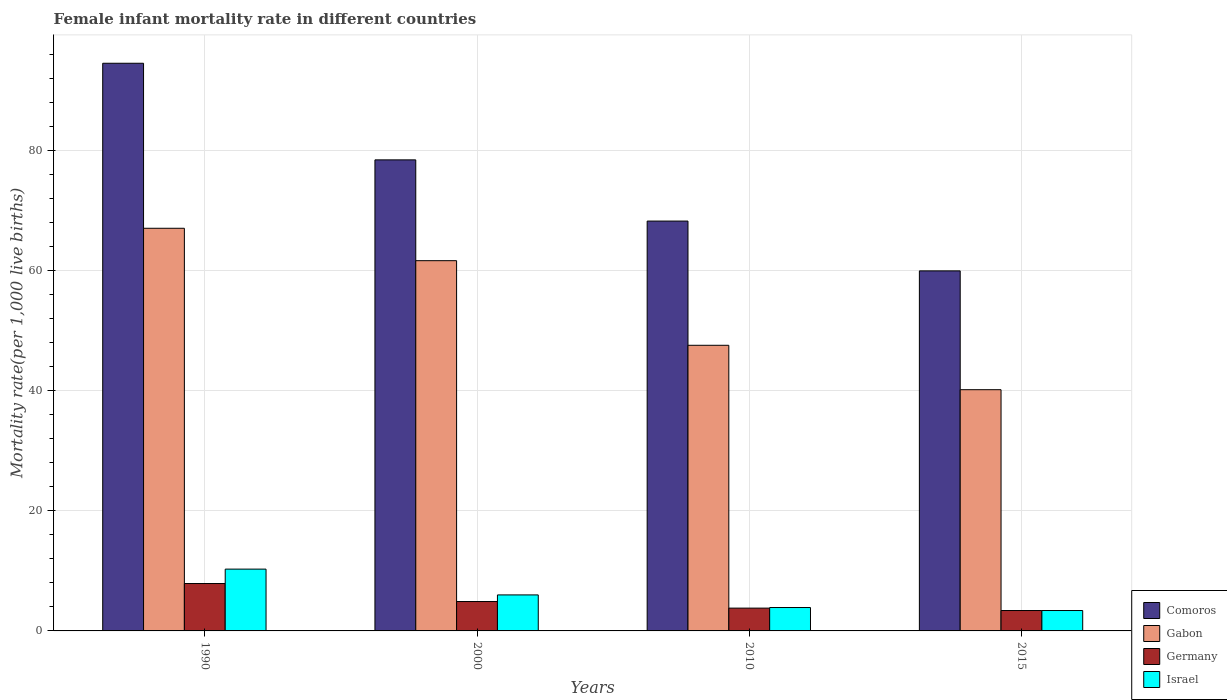Are the number of bars per tick equal to the number of legend labels?
Your answer should be compact. Yes. What is the label of the 3rd group of bars from the left?
Offer a very short reply. 2010. What is the female infant mortality rate in Germany in 2010?
Provide a short and direct response. 3.8. Across all years, what is the maximum female infant mortality rate in Gabon?
Make the answer very short. 67.1. Across all years, what is the minimum female infant mortality rate in Comoros?
Your answer should be compact. 60. In which year was the female infant mortality rate in Comoros minimum?
Your response must be concise. 2015. What is the total female infant mortality rate in Comoros in the graph?
Offer a very short reply. 301.4. What is the difference between the female infant mortality rate in Gabon in 1990 and that in 2000?
Make the answer very short. 5.4. What is the difference between the female infant mortality rate in Comoros in 2000 and the female infant mortality rate in Gabon in 2015?
Keep it short and to the point. 38.3. What is the average female infant mortality rate in Israel per year?
Ensure brevity in your answer.  5.9. In the year 2010, what is the difference between the female infant mortality rate in Comoros and female infant mortality rate in Gabon?
Your answer should be very brief. 20.7. What is the ratio of the female infant mortality rate in Comoros in 2000 to that in 2015?
Offer a very short reply. 1.31. Is the female infant mortality rate in Israel in 2000 less than that in 2010?
Keep it short and to the point. No. What is the difference between the highest and the second highest female infant mortality rate in Comoros?
Keep it short and to the point. 16.1. What does the 1st bar from the left in 1990 represents?
Offer a very short reply. Comoros. What does the 4th bar from the right in 2000 represents?
Your answer should be compact. Comoros. Is it the case that in every year, the sum of the female infant mortality rate in Comoros and female infant mortality rate in Gabon is greater than the female infant mortality rate in Israel?
Offer a terse response. Yes. How many bars are there?
Your response must be concise. 16. How many years are there in the graph?
Keep it short and to the point. 4. What is the difference between two consecutive major ticks on the Y-axis?
Your answer should be compact. 20. Does the graph contain grids?
Provide a succinct answer. Yes. Where does the legend appear in the graph?
Your answer should be compact. Bottom right. What is the title of the graph?
Provide a succinct answer. Female infant mortality rate in different countries. What is the label or title of the X-axis?
Offer a terse response. Years. What is the label or title of the Y-axis?
Offer a very short reply. Mortality rate(per 1,0 live births). What is the Mortality rate(per 1,000 live births) of Comoros in 1990?
Your response must be concise. 94.6. What is the Mortality rate(per 1,000 live births) of Gabon in 1990?
Your answer should be compact. 67.1. What is the Mortality rate(per 1,000 live births) of Germany in 1990?
Give a very brief answer. 7.9. What is the Mortality rate(per 1,000 live births) in Israel in 1990?
Make the answer very short. 10.3. What is the Mortality rate(per 1,000 live births) of Comoros in 2000?
Offer a terse response. 78.5. What is the Mortality rate(per 1,000 live births) in Gabon in 2000?
Keep it short and to the point. 61.7. What is the Mortality rate(per 1,000 live births) of Germany in 2000?
Keep it short and to the point. 4.9. What is the Mortality rate(per 1,000 live births) of Comoros in 2010?
Keep it short and to the point. 68.3. What is the Mortality rate(per 1,000 live births) of Gabon in 2010?
Your answer should be compact. 47.6. What is the Mortality rate(per 1,000 live births) of Gabon in 2015?
Your answer should be very brief. 40.2. What is the Mortality rate(per 1,000 live births) of Germany in 2015?
Provide a succinct answer. 3.4. Across all years, what is the maximum Mortality rate(per 1,000 live births) of Comoros?
Provide a succinct answer. 94.6. Across all years, what is the maximum Mortality rate(per 1,000 live births) of Gabon?
Provide a succinct answer. 67.1. Across all years, what is the maximum Mortality rate(per 1,000 live births) of Israel?
Provide a succinct answer. 10.3. Across all years, what is the minimum Mortality rate(per 1,000 live births) of Comoros?
Offer a terse response. 60. Across all years, what is the minimum Mortality rate(per 1,000 live births) of Gabon?
Keep it short and to the point. 40.2. Across all years, what is the minimum Mortality rate(per 1,000 live births) in Israel?
Provide a short and direct response. 3.4. What is the total Mortality rate(per 1,000 live births) of Comoros in the graph?
Your answer should be compact. 301.4. What is the total Mortality rate(per 1,000 live births) in Gabon in the graph?
Offer a terse response. 216.6. What is the total Mortality rate(per 1,000 live births) of Germany in the graph?
Offer a terse response. 20. What is the total Mortality rate(per 1,000 live births) of Israel in the graph?
Offer a very short reply. 23.6. What is the difference between the Mortality rate(per 1,000 live births) in Germany in 1990 and that in 2000?
Keep it short and to the point. 3. What is the difference between the Mortality rate(per 1,000 live births) of Israel in 1990 and that in 2000?
Provide a succinct answer. 4.3. What is the difference between the Mortality rate(per 1,000 live births) of Comoros in 1990 and that in 2010?
Give a very brief answer. 26.3. What is the difference between the Mortality rate(per 1,000 live births) of Gabon in 1990 and that in 2010?
Ensure brevity in your answer.  19.5. What is the difference between the Mortality rate(per 1,000 live births) of Germany in 1990 and that in 2010?
Ensure brevity in your answer.  4.1. What is the difference between the Mortality rate(per 1,000 live births) of Israel in 1990 and that in 2010?
Offer a terse response. 6.4. What is the difference between the Mortality rate(per 1,000 live births) of Comoros in 1990 and that in 2015?
Give a very brief answer. 34.6. What is the difference between the Mortality rate(per 1,000 live births) of Gabon in 1990 and that in 2015?
Ensure brevity in your answer.  26.9. What is the difference between the Mortality rate(per 1,000 live births) in Germany in 2000 and that in 2010?
Offer a terse response. 1.1. What is the difference between the Mortality rate(per 1,000 live births) in Israel in 2000 and that in 2010?
Your answer should be very brief. 2.1. What is the difference between the Mortality rate(per 1,000 live births) in Gabon in 2000 and that in 2015?
Offer a terse response. 21.5. What is the difference between the Mortality rate(per 1,000 live births) in Israel in 2000 and that in 2015?
Offer a very short reply. 2.6. What is the difference between the Mortality rate(per 1,000 live births) in Gabon in 2010 and that in 2015?
Give a very brief answer. 7.4. What is the difference between the Mortality rate(per 1,000 live births) in Israel in 2010 and that in 2015?
Make the answer very short. 0.5. What is the difference between the Mortality rate(per 1,000 live births) of Comoros in 1990 and the Mortality rate(per 1,000 live births) of Gabon in 2000?
Give a very brief answer. 32.9. What is the difference between the Mortality rate(per 1,000 live births) in Comoros in 1990 and the Mortality rate(per 1,000 live births) in Germany in 2000?
Provide a succinct answer. 89.7. What is the difference between the Mortality rate(per 1,000 live births) in Comoros in 1990 and the Mortality rate(per 1,000 live births) in Israel in 2000?
Keep it short and to the point. 88.6. What is the difference between the Mortality rate(per 1,000 live births) of Gabon in 1990 and the Mortality rate(per 1,000 live births) of Germany in 2000?
Provide a short and direct response. 62.2. What is the difference between the Mortality rate(per 1,000 live births) in Gabon in 1990 and the Mortality rate(per 1,000 live births) in Israel in 2000?
Provide a succinct answer. 61.1. What is the difference between the Mortality rate(per 1,000 live births) of Germany in 1990 and the Mortality rate(per 1,000 live births) of Israel in 2000?
Your response must be concise. 1.9. What is the difference between the Mortality rate(per 1,000 live births) of Comoros in 1990 and the Mortality rate(per 1,000 live births) of Gabon in 2010?
Your answer should be compact. 47. What is the difference between the Mortality rate(per 1,000 live births) of Comoros in 1990 and the Mortality rate(per 1,000 live births) of Germany in 2010?
Offer a terse response. 90.8. What is the difference between the Mortality rate(per 1,000 live births) in Comoros in 1990 and the Mortality rate(per 1,000 live births) in Israel in 2010?
Your answer should be compact. 90.7. What is the difference between the Mortality rate(per 1,000 live births) in Gabon in 1990 and the Mortality rate(per 1,000 live births) in Germany in 2010?
Make the answer very short. 63.3. What is the difference between the Mortality rate(per 1,000 live births) of Gabon in 1990 and the Mortality rate(per 1,000 live births) of Israel in 2010?
Offer a very short reply. 63.2. What is the difference between the Mortality rate(per 1,000 live births) of Germany in 1990 and the Mortality rate(per 1,000 live births) of Israel in 2010?
Provide a short and direct response. 4. What is the difference between the Mortality rate(per 1,000 live births) in Comoros in 1990 and the Mortality rate(per 1,000 live births) in Gabon in 2015?
Make the answer very short. 54.4. What is the difference between the Mortality rate(per 1,000 live births) of Comoros in 1990 and the Mortality rate(per 1,000 live births) of Germany in 2015?
Make the answer very short. 91.2. What is the difference between the Mortality rate(per 1,000 live births) in Comoros in 1990 and the Mortality rate(per 1,000 live births) in Israel in 2015?
Keep it short and to the point. 91.2. What is the difference between the Mortality rate(per 1,000 live births) of Gabon in 1990 and the Mortality rate(per 1,000 live births) of Germany in 2015?
Provide a succinct answer. 63.7. What is the difference between the Mortality rate(per 1,000 live births) of Gabon in 1990 and the Mortality rate(per 1,000 live births) of Israel in 2015?
Give a very brief answer. 63.7. What is the difference between the Mortality rate(per 1,000 live births) of Germany in 1990 and the Mortality rate(per 1,000 live births) of Israel in 2015?
Keep it short and to the point. 4.5. What is the difference between the Mortality rate(per 1,000 live births) in Comoros in 2000 and the Mortality rate(per 1,000 live births) in Gabon in 2010?
Make the answer very short. 30.9. What is the difference between the Mortality rate(per 1,000 live births) of Comoros in 2000 and the Mortality rate(per 1,000 live births) of Germany in 2010?
Make the answer very short. 74.7. What is the difference between the Mortality rate(per 1,000 live births) in Comoros in 2000 and the Mortality rate(per 1,000 live births) in Israel in 2010?
Give a very brief answer. 74.6. What is the difference between the Mortality rate(per 1,000 live births) of Gabon in 2000 and the Mortality rate(per 1,000 live births) of Germany in 2010?
Offer a very short reply. 57.9. What is the difference between the Mortality rate(per 1,000 live births) in Gabon in 2000 and the Mortality rate(per 1,000 live births) in Israel in 2010?
Your answer should be compact. 57.8. What is the difference between the Mortality rate(per 1,000 live births) in Comoros in 2000 and the Mortality rate(per 1,000 live births) in Gabon in 2015?
Offer a terse response. 38.3. What is the difference between the Mortality rate(per 1,000 live births) in Comoros in 2000 and the Mortality rate(per 1,000 live births) in Germany in 2015?
Give a very brief answer. 75.1. What is the difference between the Mortality rate(per 1,000 live births) in Comoros in 2000 and the Mortality rate(per 1,000 live births) in Israel in 2015?
Offer a very short reply. 75.1. What is the difference between the Mortality rate(per 1,000 live births) in Gabon in 2000 and the Mortality rate(per 1,000 live births) in Germany in 2015?
Provide a short and direct response. 58.3. What is the difference between the Mortality rate(per 1,000 live births) of Gabon in 2000 and the Mortality rate(per 1,000 live births) of Israel in 2015?
Your response must be concise. 58.3. What is the difference between the Mortality rate(per 1,000 live births) in Comoros in 2010 and the Mortality rate(per 1,000 live births) in Gabon in 2015?
Provide a succinct answer. 28.1. What is the difference between the Mortality rate(per 1,000 live births) in Comoros in 2010 and the Mortality rate(per 1,000 live births) in Germany in 2015?
Keep it short and to the point. 64.9. What is the difference between the Mortality rate(per 1,000 live births) of Comoros in 2010 and the Mortality rate(per 1,000 live births) of Israel in 2015?
Your answer should be very brief. 64.9. What is the difference between the Mortality rate(per 1,000 live births) in Gabon in 2010 and the Mortality rate(per 1,000 live births) in Germany in 2015?
Your answer should be very brief. 44.2. What is the difference between the Mortality rate(per 1,000 live births) of Gabon in 2010 and the Mortality rate(per 1,000 live births) of Israel in 2015?
Provide a succinct answer. 44.2. What is the difference between the Mortality rate(per 1,000 live births) in Germany in 2010 and the Mortality rate(per 1,000 live births) in Israel in 2015?
Give a very brief answer. 0.4. What is the average Mortality rate(per 1,000 live births) in Comoros per year?
Give a very brief answer. 75.35. What is the average Mortality rate(per 1,000 live births) in Gabon per year?
Ensure brevity in your answer.  54.15. What is the average Mortality rate(per 1,000 live births) of Germany per year?
Your answer should be very brief. 5. In the year 1990, what is the difference between the Mortality rate(per 1,000 live births) of Comoros and Mortality rate(per 1,000 live births) of Germany?
Offer a very short reply. 86.7. In the year 1990, what is the difference between the Mortality rate(per 1,000 live births) in Comoros and Mortality rate(per 1,000 live births) in Israel?
Offer a terse response. 84.3. In the year 1990, what is the difference between the Mortality rate(per 1,000 live births) of Gabon and Mortality rate(per 1,000 live births) of Germany?
Keep it short and to the point. 59.2. In the year 1990, what is the difference between the Mortality rate(per 1,000 live births) in Gabon and Mortality rate(per 1,000 live births) in Israel?
Your response must be concise. 56.8. In the year 2000, what is the difference between the Mortality rate(per 1,000 live births) of Comoros and Mortality rate(per 1,000 live births) of Gabon?
Ensure brevity in your answer.  16.8. In the year 2000, what is the difference between the Mortality rate(per 1,000 live births) in Comoros and Mortality rate(per 1,000 live births) in Germany?
Make the answer very short. 73.6. In the year 2000, what is the difference between the Mortality rate(per 1,000 live births) of Comoros and Mortality rate(per 1,000 live births) of Israel?
Give a very brief answer. 72.5. In the year 2000, what is the difference between the Mortality rate(per 1,000 live births) in Gabon and Mortality rate(per 1,000 live births) in Germany?
Offer a very short reply. 56.8. In the year 2000, what is the difference between the Mortality rate(per 1,000 live births) of Gabon and Mortality rate(per 1,000 live births) of Israel?
Provide a short and direct response. 55.7. In the year 2010, what is the difference between the Mortality rate(per 1,000 live births) of Comoros and Mortality rate(per 1,000 live births) of Gabon?
Offer a terse response. 20.7. In the year 2010, what is the difference between the Mortality rate(per 1,000 live births) in Comoros and Mortality rate(per 1,000 live births) in Germany?
Ensure brevity in your answer.  64.5. In the year 2010, what is the difference between the Mortality rate(per 1,000 live births) of Comoros and Mortality rate(per 1,000 live births) of Israel?
Offer a very short reply. 64.4. In the year 2010, what is the difference between the Mortality rate(per 1,000 live births) of Gabon and Mortality rate(per 1,000 live births) of Germany?
Your response must be concise. 43.8. In the year 2010, what is the difference between the Mortality rate(per 1,000 live births) of Gabon and Mortality rate(per 1,000 live births) of Israel?
Provide a succinct answer. 43.7. In the year 2015, what is the difference between the Mortality rate(per 1,000 live births) of Comoros and Mortality rate(per 1,000 live births) of Gabon?
Keep it short and to the point. 19.8. In the year 2015, what is the difference between the Mortality rate(per 1,000 live births) in Comoros and Mortality rate(per 1,000 live births) in Germany?
Offer a very short reply. 56.6. In the year 2015, what is the difference between the Mortality rate(per 1,000 live births) of Comoros and Mortality rate(per 1,000 live births) of Israel?
Keep it short and to the point. 56.6. In the year 2015, what is the difference between the Mortality rate(per 1,000 live births) in Gabon and Mortality rate(per 1,000 live births) in Germany?
Offer a very short reply. 36.8. In the year 2015, what is the difference between the Mortality rate(per 1,000 live births) of Gabon and Mortality rate(per 1,000 live births) of Israel?
Offer a terse response. 36.8. In the year 2015, what is the difference between the Mortality rate(per 1,000 live births) of Germany and Mortality rate(per 1,000 live births) of Israel?
Keep it short and to the point. 0. What is the ratio of the Mortality rate(per 1,000 live births) in Comoros in 1990 to that in 2000?
Your response must be concise. 1.21. What is the ratio of the Mortality rate(per 1,000 live births) of Gabon in 1990 to that in 2000?
Offer a very short reply. 1.09. What is the ratio of the Mortality rate(per 1,000 live births) of Germany in 1990 to that in 2000?
Offer a very short reply. 1.61. What is the ratio of the Mortality rate(per 1,000 live births) in Israel in 1990 to that in 2000?
Make the answer very short. 1.72. What is the ratio of the Mortality rate(per 1,000 live births) of Comoros in 1990 to that in 2010?
Your answer should be compact. 1.39. What is the ratio of the Mortality rate(per 1,000 live births) in Gabon in 1990 to that in 2010?
Offer a very short reply. 1.41. What is the ratio of the Mortality rate(per 1,000 live births) of Germany in 1990 to that in 2010?
Provide a short and direct response. 2.08. What is the ratio of the Mortality rate(per 1,000 live births) of Israel in 1990 to that in 2010?
Make the answer very short. 2.64. What is the ratio of the Mortality rate(per 1,000 live births) in Comoros in 1990 to that in 2015?
Provide a succinct answer. 1.58. What is the ratio of the Mortality rate(per 1,000 live births) in Gabon in 1990 to that in 2015?
Ensure brevity in your answer.  1.67. What is the ratio of the Mortality rate(per 1,000 live births) of Germany in 1990 to that in 2015?
Your answer should be very brief. 2.32. What is the ratio of the Mortality rate(per 1,000 live births) of Israel in 1990 to that in 2015?
Give a very brief answer. 3.03. What is the ratio of the Mortality rate(per 1,000 live births) in Comoros in 2000 to that in 2010?
Your answer should be compact. 1.15. What is the ratio of the Mortality rate(per 1,000 live births) in Gabon in 2000 to that in 2010?
Make the answer very short. 1.3. What is the ratio of the Mortality rate(per 1,000 live births) in Germany in 2000 to that in 2010?
Give a very brief answer. 1.29. What is the ratio of the Mortality rate(per 1,000 live births) in Israel in 2000 to that in 2010?
Provide a short and direct response. 1.54. What is the ratio of the Mortality rate(per 1,000 live births) of Comoros in 2000 to that in 2015?
Offer a very short reply. 1.31. What is the ratio of the Mortality rate(per 1,000 live births) of Gabon in 2000 to that in 2015?
Your response must be concise. 1.53. What is the ratio of the Mortality rate(per 1,000 live births) of Germany in 2000 to that in 2015?
Offer a very short reply. 1.44. What is the ratio of the Mortality rate(per 1,000 live births) of Israel in 2000 to that in 2015?
Provide a succinct answer. 1.76. What is the ratio of the Mortality rate(per 1,000 live births) of Comoros in 2010 to that in 2015?
Ensure brevity in your answer.  1.14. What is the ratio of the Mortality rate(per 1,000 live births) in Gabon in 2010 to that in 2015?
Make the answer very short. 1.18. What is the ratio of the Mortality rate(per 1,000 live births) in Germany in 2010 to that in 2015?
Your response must be concise. 1.12. What is the ratio of the Mortality rate(per 1,000 live births) in Israel in 2010 to that in 2015?
Give a very brief answer. 1.15. What is the difference between the highest and the second highest Mortality rate(per 1,000 live births) in Comoros?
Offer a terse response. 16.1. What is the difference between the highest and the second highest Mortality rate(per 1,000 live births) of Gabon?
Ensure brevity in your answer.  5.4. What is the difference between the highest and the second highest Mortality rate(per 1,000 live births) in Israel?
Your answer should be compact. 4.3. What is the difference between the highest and the lowest Mortality rate(per 1,000 live births) of Comoros?
Your answer should be compact. 34.6. What is the difference between the highest and the lowest Mortality rate(per 1,000 live births) in Gabon?
Keep it short and to the point. 26.9. What is the difference between the highest and the lowest Mortality rate(per 1,000 live births) in Germany?
Offer a terse response. 4.5. What is the difference between the highest and the lowest Mortality rate(per 1,000 live births) in Israel?
Your answer should be very brief. 6.9. 